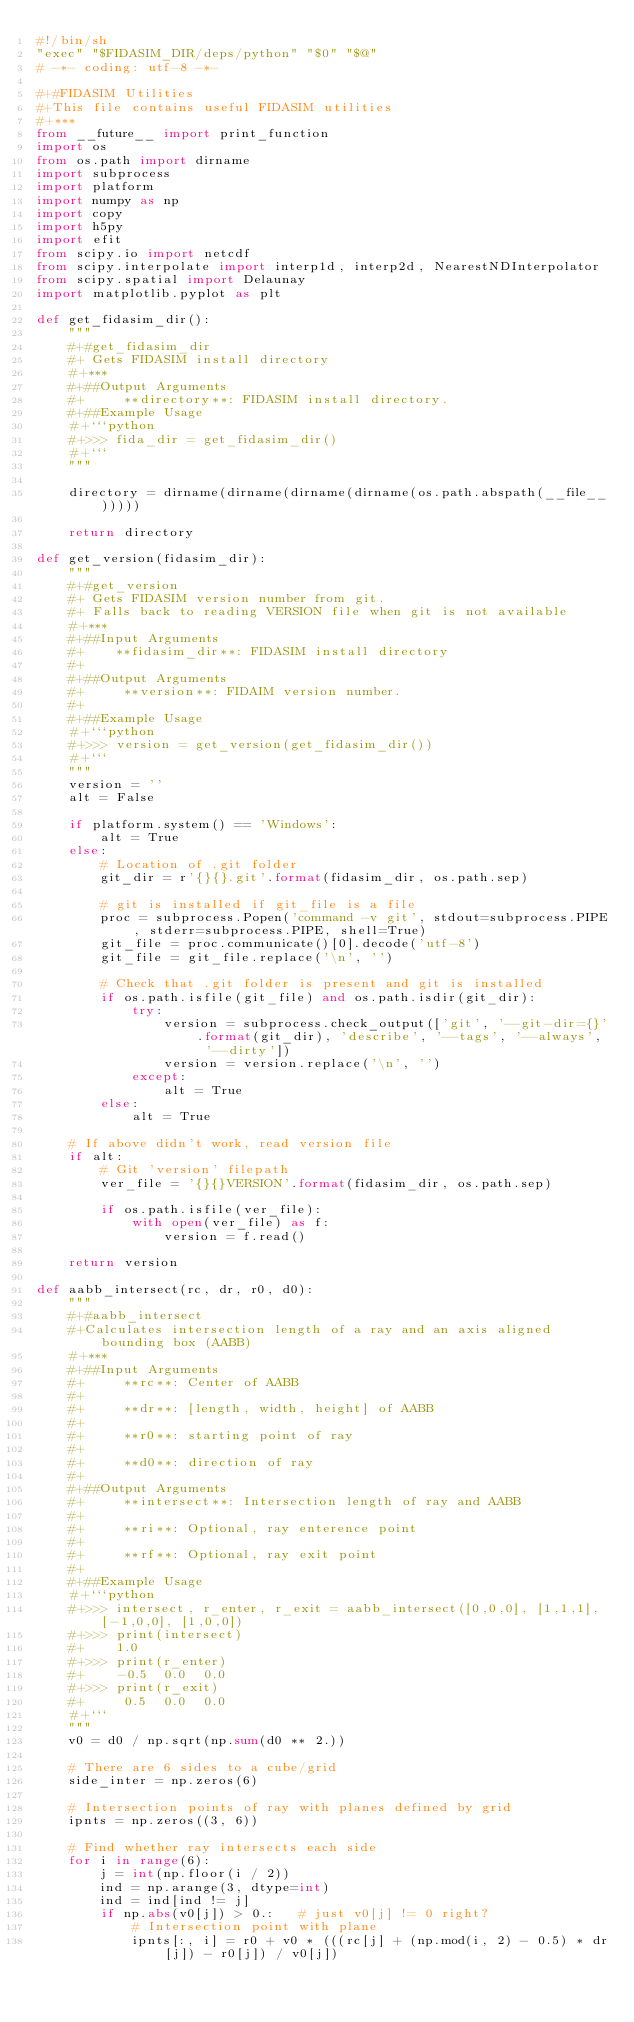<code> <loc_0><loc_0><loc_500><loc_500><_Python_>#!/bin/sh
"exec" "$FIDASIM_DIR/deps/python" "$0" "$@"
# -*- coding: utf-8 -*-

#+#FIDASIM Utilities
#+This file contains useful FIDASIM utilities
#+***
from __future__ import print_function
import os
from os.path import dirname
import subprocess
import platform
import numpy as np
import copy
import h5py
import efit
from scipy.io import netcdf
from scipy.interpolate import interp1d, interp2d, NearestNDInterpolator
from scipy.spatial import Delaunay
import matplotlib.pyplot as plt

def get_fidasim_dir():
    """
    #+#get_fidasim_dir
    #+ Gets FIDASIM install directory
    #+***
    #+##Output Arguments
    #+     **directory**: FIDASIM install directory.
    #+##Example Usage
    #+```python
    #+>>> fida_dir = get_fidasim_dir()
    #+```
    """

    directory = dirname(dirname(dirname(dirname(os.path.abspath(__file__)))))

    return directory

def get_version(fidasim_dir):
    """
    #+#get_version
    #+ Gets FIDASIM version number from git.
    #+ Falls back to reading VERSION file when git is not available
    #+***
    #+##Input Arguments
    #+    **fidasim_dir**: FIDASIM install directory
    #+
    #+##Output Arguments
    #+     **version**: FIDAIM version number.
    #+
    #+##Example Usage
    #+```python
    #+>>> version = get_version(get_fidasim_dir())
    #+```
    """
    version = ''
    alt = False

    if platform.system() == 'Windows':
        alt = True
    else:
        # Location of .git folder
        git_dir = r'{}{}.git'.format(fidasim_dir, os.path.sep)

        # git is installed if git_file is a file
        proc = subprocess.Popen('command -v git', stdout=subprocess.PIPE, stderr=subprocess.PIPE, shell=True)
        git_file = proc.communicate()[0].decode('utf-8')
        git_file = git_file.replace('\n', '')

        # Check that .git folder is present and git is installed
        if os.path.isfile(git_file) and os.path.isdir(git_dir):
            try:
                version = subprocess.check_output(['git', '--git-dir={}'.format(git_dir), 'describe', '--tags', '--always', '--dirty'])
                version = version.replace('\n', '')
            except:
                alt = True
        else:
            alt = True

    # If above didn't work, read version file
    if alt:
        # Git 'version' filepath
        ver_file = '{}{}VERSION'.format(fidasim_dir, os.path.sep)

        if os.path.isfile(ver_file):
            with open(ver_file) as f:
                version = f.read()

    return version

def aabb_intersect(rc, dr, r0, d0):
    """
    #+#aabb_intersect
    #+Calculates intersection length of a ray and an axis aligned bounding box (AABB)
    #+***
    #+##Input Arguments
    #+     **rc**: Center of AABB
    #+
    #+     **dr**: [length, width, height] of AABB
    #+
    #+     **r0**: starting point of ray
    #+
    #+     **d0**: direction of ray
    #+
    #+##Output Arguments
    #+     **intersect**: Intersection length of ray and AABB
    #+
    #+     **ri**: Optional, ray enterence point
    #+
    #+     **rf**: Optional, ray exit point
    #+
    #+##Example Usage
    #+```python
    #+>>> intersect, r_enter, r_exit = aabb_intersect([0,0,0], [1,1,1], [-1,0,0], [1,0,0])
    #+>>> print(intersect)
    #+    1.0
    #+>>> print(r_enter)
    #+    -0.5  0.0  0.0
    #+>>> print(r_exit)
    #+     0.5  0.0  0.0
    #+```
    """
    v0 = d0 / np.sqrt(np.sum(d0 ** 2.))

    # There are 6 sides to a cube/grid
    side_inter = np.zeros(6)

    # Intersection points of ray with planes defined by grid
    ipnts = np.zeros((3, 6))

    # Find whether ray intersects each side
    for i in range(6):
        j = int(np.floor(i / 2))
        ind = np.arange(3, dtype=int)
        ind = ind[ind != j]
        if np.abs(v0[j]) > 0.:   # just v0[j] != 0 right?
            # Intersection point with plane
            ipnts[:, i] = r0 + v0 * (((rc[j] + (np.mod(i, 2) - 0.5) * dr[j]) - r0[j]) / v0[j])
</code> 